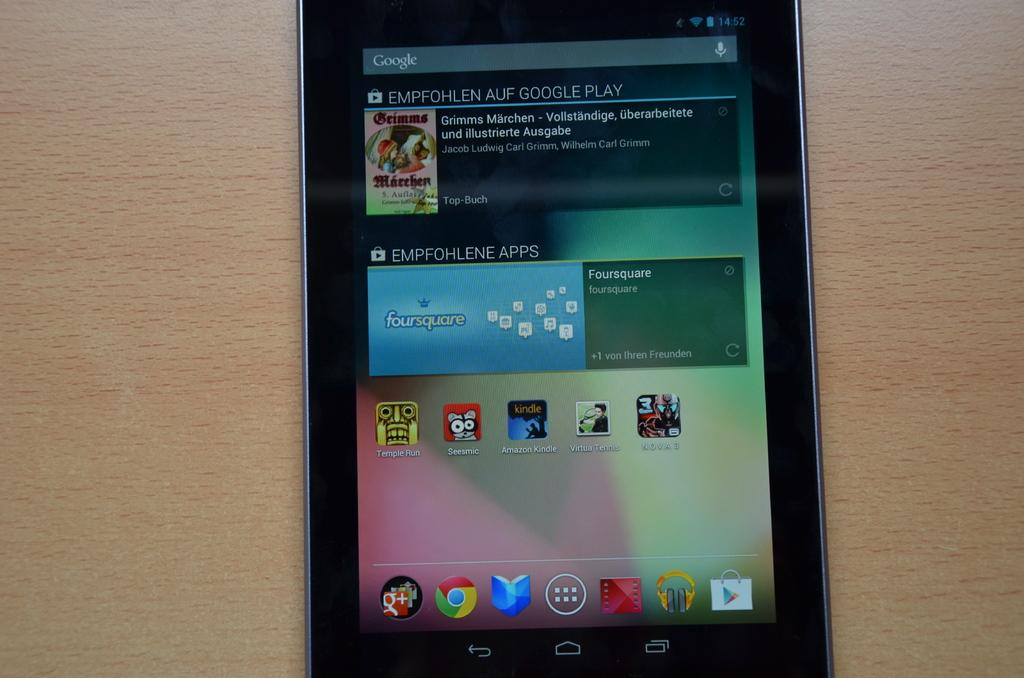What electronic device is visible in the image? There is a mobile phone in the image. What can be seen on the mobile phone? The mobile phone has a display. On what surface is the mobile phone placed? The mobile phone is placed on a wooden board. Can you see a giraffe in the image? No, there is no giraffe present in the image. Is there a volcano visible in the image? No, there is no volcano present in the image. 